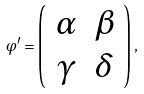<formula> <loc_0><loc_0><loc_500><loc_500>\varphi ^ { \prime } = \left ( \begin{array} { c c } \alpha & \beta \\ \gamma & \delta \end{array} \right ) ,</formula> 